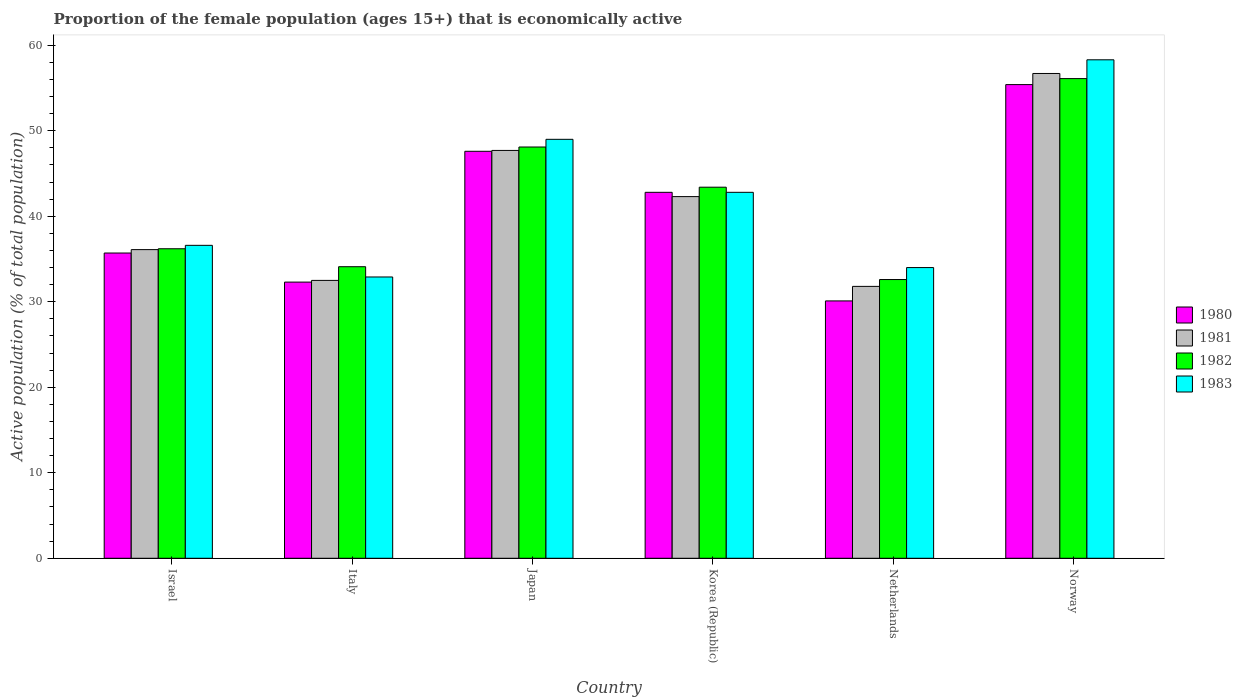How many different coloured bars are there?
Give a very brief answer. 4. How many groups of bars are there?
Make the answer very short. 6. Are the number of bars per tick equal to the number of legend labels?
Offer a very short reply. Yes. Are the number of bars on each tick of the X-axis equal?
Give a very brief answer. Yes. What is the label of the 1st group of bars from the left?
Provide a short and direct response. Israel. In how many cases, is the number of bars for a given country not equal to the number of legend labels?
Give a very brief answer. 0. What is the proportion of the female population that is economically active in 1980 in Norway?
Ensure brevity in your answer.  55.4. Across all countries, what is the maximum proportion of the female population that is economically active in 1982?
Your answer should be compact. 56.1. Across all countries, what is the minimum proportion of the female population that is economically active in 1980?
Give a very brief answer. 30.1. What is the total proportion of the female population that is economically active in 1981 in the graph?
Make the answer very short. 247.1. What is the difference between the proportion of the female population that is economically active in 1982 in Korea (Republic) and the proportion of the female population that is economically active in 1981 in Israel?
Provide a short and direct response. 7.3. What is the average proportion of the female population that is economically active in 1983 per country?
Give a very brief answer. 42.27. What is the difference between the proportion of the female population that is economically active of/in 1982 and proportion of the female population that is economically active of/in 1980 in Italy?
Give a very brief answer. 1.8. What is the ratio of the proportion of the female population that is economically active in 1980 in Korea (Republic) to that in Norway?
Provide a short and direct response. 0.77. Is the proportion of the female population that is economically active in 1981 in Israel less than that in Netherlands?
Your answer should be very brief. No. What is the difference between the highest and the lowest proportion of the female population that is economically active in 1983?
Give a very brief answer. 25.4. In how many countries, is the proportion of the female population that is economically active in 1983 greater than the average proportion of the female population that is economically active in 1983 taken over all countries?
Offer a terse response. 3. What does the 3rd bar from the right in Norway represents?
Provide a succinct answer. 1981. Is it the case that in every country, the sum of the proportion of the female population that is economically active in 1981 and proportion of the female population that is economically active in 1983 is greater than the proportion of the female population that is economically active in 1982?
Provide a short and direct response. Yes. How many countries are there in the graph?
Keep it short and to the point. 6. Does the graph contain any zero values?
Your response must be concise. No. Does the graph contain grids?
Ensure brevity in your answer.  No. Where does the legend appear in the graph?
Provide a short and direct response. Center right. How many legend labels are there?
Give a very brief answer. 4. What is the title of the graph?
Your answer should be very brief. Proportion of the female population (ages 15+) that is economically active. Does "1962" appear as one of the legend labels in the graph?
Offer a terse response. No. What is the label or title of the X-axis?
Your answer should be compact. Country. What is the label or title of the Y-axis?
Your answer should be very brief. Active population (% of total population). What is the Active population (% of total population) in 1980 in Israel?
Provide a short and direct response. 35.7. What is the Active population (% of total population) in 1981 in Israel?
Offer a terse response. 36.1. What is the Active population (% of total population) in 1982 in Israel?
Ensure brevity in your answer.  36.2. What is the Active population (% of total population) in 1983 in Israel?
Ensure brevity in your answer.  36.6. What is the Active population (% of total population) of 1980 in Italy?
Your response must be concise. 32.3. What is the Active population (% of total population) in 1981 in Italy?
Offer a terse response. 32.5. What is the Active population (% of total population) of 1982 in Italy?
Provide a short and direct response. 34.1. What is the Active population (% of total population) of 1983 in Italy?
Make the answer very short. 32.9. What is the Active population (% of total population) of 1980 in Japan?
Provide a succinct answer. 47.6. What is the Active population (% of total population) in 1981 in Japan?
Provide a succinct answer. 47.7. What is the Active population (% of total population) of 1982 in Japan?
Provide a succinct answer. 48.1. What is the Active population (% of total population) of 1980 in Korea (Republic)?
Your response must be concise. 42.8. What is the Active population (% of total population) of 1981 in Korea (Republic)?
Offer a terse response. 42.3. What is the Active population (% of total population) of 1982 in Korea (Republic)?
Keep it short and to the point. 43.4. What is the Active population (% of total population) of 1983 in Korea (Republic)?
Your answer should be compact. 42.8. What is the Active population (% of total population) in 1980 in Netherlands?
Provide a short and direct response. 30.1. What is the Active population (% of total population) in 1981 in Netherlands?
Provide a succinct answer. 31.8. What is the Active population (% of total population) of 1982 in Netherlands?
Make the answer very short. 32.6. What is the Active population (% of total population) of 1983 in Netherlands?
Provide a short and direct response. 34. What is the Active population (% of total population) in 1980 in Norway?
Offer a terse response. 55.4. What is the Active population (% of total population) of 1981 in Norway?
Ensure brevity in your answer.  56.7. What is the Active population (% of total population) of 1982 in Norway?
Provide a succinct answer. 56.1. What is the Active population (% of total population) of 1983 in Norway?
Keep it short and to the point. 58.3. Across all countries, what is the maximum Active population (% of total population) of 1980?
Your response must be concise. 55.4. Across all countries, what is the maximum Active population (% of total population) in 1981?
Provide a succinct answer. 56.7. Across all countries, what is the maximum Active population (% of total population) in 1982?
Offer a terse response. 56.1. Across all countries, what is the maximum Active population (% of total population) of 1983?
Give a very brief answer. 58.3. Across all countries, what is the minimum Active population (% of total population) of 1980?
Keep it short and to the point. 30.1. Across all countries, what is the minimum Active population (% of total population) of 1981?
Provide a succinct answer. 31.8. Across all countries, what is the minimum Active population (% of total population) of 1982?
Offer a terse response. 32.6. Across all countries, what is the minimum Active population (% of total population) in 1983?
Ensure brevity in your answer.  32.9. What is the total Active population (% of total population) in 1980 in the graph?
Offer a very short reply. 243.9. What is the total Active population (% of total population) in 1981 in the graph?
Keep it short and to the point. 247.1. What is the total Active population (% of total population) of 1982 in the graph?
Your answer should be compact. 250.5. What is the total Active population (% of total population) in 1983 in the graph?
Keep it short and to the point. 253.6. What is the difference between the Active population (% of total population) of 1981 in Israel and that in Italy?
Your response must be concise. 3.6. What is the difference between the Active population (% of total population) of 1982 in Israel and that in Italy?
Your answer should be very brief. 2.1. What is the difference between the Active population (% of total population) in 1983 in Israel and that in Italy?
Ensure brevity in your answer.  3.7. What is the difference between the Active population (% of total population) in 1981 in Israel and that in Japan?
Offer a very short reply. -11.6. What is the difference between the Active population (% of total population) in 1983 in Israel and that in Japan?
Offer a terse response. -12.4. What is the difference between the Active population (% of total population) of 1980 in Israel and that in Korea (Republic)?
Offer a terse response. -7.1. What is the difference between the Active population (% of total population) of 1982 in Israel and that in Korea (Republic)?
Ensure brevity in your answer.  -7.2. What is the difference between the Active population (% of total population) in 1981 in Israel and that in Netherlands?
Offer a very short reply. 4.3. What is the difference between the Active population (% of total population) of 1980 in Israel and that in Norway?
Make the answer very short. -19.7. What is the difference between the Active population (% of total population) of 1981 in Israel and that in Norway?
Provide a succinct answer. -20.6. What is the difference between the Active population (% of total population) in 1982 in Israel and that in Norway?
Offer a terse response. -19.9. What is the difference between the Active population (% of total population) of 1983 in Israel and that in Norway?
Make the answer very short. -21.7. What is the difference between the Active population (% of total population) of 1980 in Italy and that in Japan?
Your answer should be compact. -15.3. What is the difference between the Active population (% of total population) of 1981 in Italy and that in Japan?
Provide a succinct answer. -15.2. What is the difference between the Active population (% of total population) of 1983 in Italy and that in Japan?
Make the answer very short. -16.1. What is the difference between the Active population (% of total population) of 1981 in Italy and that in Korea (Republic)?
Provide a succinct answer. -9.8. What is the difference between the Active population (% of total population) of 1982 in Italy and that in Korea (Republic)?
Your response must be concise. -9.3. What is the difference between the Active population (% of total population) in 1983 in Italy and that in Korea (Republic)?
Offer a very short reply. -9.9. What is the difference between the Active population (% of total population) in 1983 in Italy and that in Netherlands?
Your answer should be compact. -1.1. What is the difference between the Active population (% of total population) in 1980 in Italy and that in Norway?
Provide a succinct answer. -23.1. What is the difference between the Active population (% of total population) of 1981 in Italy and that in Norway?
Keep it short and to the point. -24.2. What is the difference between the Active population (% of total population) in 1982 in Italy and that in Norway?
Ensure brevity in your answer.  -22. What is the difference between the Active population (% of total population) in 1983 in Italy and that in Norway?
Your answer should be compact. -25.4. What is the difference between the Active population (% of total population) of 1980 in Japan and that in Korea (Republic)?
Provide a short and direct response. 4.8. What is the difference between the Active population (% of total population) of 1982 in Japan and that in Korea (Republic)?
Keep it short and to the point. 4.7. What is the difference between the Active population (% of total population) of 1980 in Japan and that in Netherlands?
Ensure brevity in your answer.  17.5. What is the difference between the Active population (% of total population) of 1981 in Japan and that in Netherlands?
Provide a short and direct response. 15.9. What is the difference between the Active population (% of total population) in 1982 in Japan and that in Netherlands?
Give a very brief answer. 15.5. What is the difference between the Active population (% of total population) in 1980 in Japan and that in Norway?
Ensure brevity in your answer.  -7.8. What is the difference between the Active population (% of total population) of 1983 in Japan and that in Norway?
Make the answer very short. -9.3. What is the difference between the Active population (% of total population) in 1982 in Korea (Republic) and that in Netherlands?
Provide a succinct answer. 10.8. What is the difference between the Active population (% of total population) of 1983 in Korea (Republic) and that in Netherlands?
Provide a short and direct response. 8.8. What is the difference between the Active population (% of total population) in 1980 in Korea (Republic) and that in Norway?
Your answer should be compact. -12.6. What is the difference between the Active population (% of total population) in 1981 in Korea (Republic) and that in Norway?
Give a very brief answer. -14.4. What is the difference between the Active population (% of total population) in 1982 in Korea (Republic) and that in Norway?
Give a very brief answer. -12.7. What is the difference between the Active population (% of total population) in 1983 in Korea (Republic) and that in Norway?
Make the answer very short. -15.5. What is the difference between the Active population (% of total population) in 1980 in Netherlands and that in Norway?
Offer a very short reply. -25.3. What is the difference between the Active population (% of total population) of 1981 in Netherlands and that in Norway?
Give a very brief answer. -24.9. What is the difference between the Active population (% of total population) of 1982 in Netherlands and that in Norway?
Your answer should be very brief. -23.5. What is the difference between the Active population (% of total population) in 1983 in Netherlands and that in Norway?
Keep it short and to the point. -24.3. What is the difference between the Active population (% of total population) in 1980 in Israel and the Active population (% of total population) in 1981 in Italy?
Your answer should be very brief. 3.2. What is the difference between the Active population (% of total population) in 1980 in Israel and the Active population (% of total population) in 1982 in Italy?
Offer a terse response. 1.6. What is the difference between the Active population (% of total population) in 1980 in Israel and the Active population (% of total population) in 1983 in Italy?
Ensure brevity in your answer.  2.8. What is the difference between the Active population (% of total population) of 1980 in Israel and the Active population (% of total population) of 1981 in Japan?
Your answer should be compact. -12. What is the difference between the Active population (% of total population) of 1980 in Israel and the Active population (% of total population) of 1982 in Japan?
Ensure brevity in your answer.  -12.4. What is the difference between the Active population (% of total population) of 1981 in Israel and the Active population (% of total population) of 1983 in Japan?
Offer a very short reply. -12.9. What is the difference between the Active population (% of total population) of 1981 in Israel and the Active population (% of total population) of 1982 in Korea (Republic)?
Your answer should be compact. -7.3. What is the difference between the Active population (% of total population) of 1981 in Israel and the Active population (% of total population) of 1983 in Korea (Republic)?
Offer a terse response. -6.7. What is the difference between the Active population (% of total population) in 1980 in Israel and the Active population (% of total population) in 1981 in Netherlands?
Provide a short and direct response. 3.9. What is the difference between the Active population (% of total population) in 1980 in Israel and the Active population (% of total population) in 1982 in Netherlands?
Your response must be concise. 3.1. What is the difference between the Active population (% of total population) of 1981 in Israel and the Active population (% of total population) of 1983 in Netherlands?
Ensure brevity in your answer.  2.1. What is the difference between the Active population (% of total population) of 1982 in Israel and the Active population (% of total population) of 1983 in Netherlands?
Your answer should be compact. 2.2. What is the difference between the Active population (% of total population) in 1980 in Israel and the Active population (% of total population) in 1981 in Norway?
Make the answer very short. -21. What is the difference between the Active population (% of total population) in 1980 in Israel and the Active population (% of total population) in 1982 in Norway?
Your answer should be very brief. -20.4. What is the difference between the Active population (% of total population) of 1980 in Israel and the Active population (% of total population) of 1983 in Norway?
Provide a succinct answer. -22.6. What is the difference between the Active population (% of total population) in 1981 in Israel and the Active population (% of total population) in 1982 in Norway?
Provide a short and direct response. -20. What is the difference between the Active population (% of total population) in 1981 in Israel and the Active population (% of total population) in 1983 in Norway?
Make the answer very short. -22.2. What is the difference between the Active population (% of total population) in 1982 in Israel and the Active population (% of total population) in 1983 in Norway?
Keep it short and to the point. -22.1. What is the difference between the Active population (% of total population) in 1980 in Italy and the Active population (% of total population) in 1981 in Japan?
Your answer should be very brief. -15.4. What is the difference between the Active population (% of total population) in 1980 in Italy and the Active population (% of total population) in 1982 in Japan?
Ensure brevity in your answer.  -15.8. What is the difference between the Active population (% of total population) of 1980 in Italy and the Active population (% of total population) of 1983 in Japan?
Offer a very short reply. -16.7. What is the difference between the Active population (% of total population) of 1981 in Italy and the Active population (% of total population) of 1982 in Japan?
Ensure brevity in your answer.  -15.6. What is the difference between the Active population (% of total population) of 1981 in Italy and the Active population (% of total population) of 1983 in Japan?
Your response must be concise. -16.5. What is the difference between the Active population (% of total population) in 1982 in Italy and the Active population (% of total population) in 1983 in Japan?
Offer a very short reply. -14.9. What is the difference between the Active population (% of total population) of 1980 in Italy and the Active population (% of total population) of 1983 in Korea (Republic)?
Your answer should be very brief. -10.5. What is the difference between the Active population (% of total population) of 1981 in Italy and the Active population (% of total population) of 1982 in Korea (Republic)?
Offer a very short reply. -10.9. What is the difference between the Active population (% of total population) of 1980 in Italy and the Active population (% of total population) of 1981 in Netherlands?
Give a very brief answer. 0.5. What is the difference between the Active population (% of total population) in 1980 in Italy and the Active population (% of total population) in 1982 in Netherlands?
Your answer should be compact. -0.3. What is the difference between the Active population (% of total population) in 1981 in Italy and the Active population (% of total population) in 1982 in Netherlands?
Provide a succinct answer. -0.1. What is the difference between the Active population (% of total population) in 1981 in Italy and the Active population (% of total population) in 1983 in Netherlands?
Offer a very short reply. -1.5. What is the difference between the Active population (% of total population) in 1982 in Italy and the Active population (% of total population) in 1983 in Netherlands?
Your response must be concise. 0.1. What is the difference between the Active population (% of total population) of 1980 in Italy and the Active population (% of total population) of 1981 in Norway?
Your answer should be very brief. -24.4. What is the difference between the Active population (% of total population) of 1980 in Italy and the Active population (% of total population) of 1982 in Norway?
Offer a terse response. -23.8. What is the difference between the Active population (% of total population) of 1981 in Italy and the Active population (% of total population) of 1982 in Norway?
Keep it short and to the point. -23.6. What is the difference between the Active population (% of total population) of 1981 in Italy and the Active population (% of total population) of 1983 in Norway?
Keep it short and to the point. -25.8. What is the difference between the Active population (% of total population) of 1982 in Italy and the Active population (% of total population) of 1983 in Norway?
Your answer should be compact. -24.2. What is the difference between the Active population (% of total population) in 1980 in Japan and the Active population (% of total population) in 1983 in Korea (Republic)?
Provide a succinct answer. 4.8. What is the difference between the Active population (% of total population) of 1981 in Japan and the Active population (% of total population) of 1982 in Korea (Republic)?
Your answer should be very brief. 4.3. What is the difference between the Active population (% of total population) of 1981 in Japan and the Active population (% of total population) of 1983 in Korea (Republic)?
Keep it short and to the point. 4.9. What is the difference between the Active population (% of total population) of 1982 in Japan and the Active population (% of total population) of 1983 in Korea (Republic)?
Keep it short and to the point. 5.3. What is the difference between the Active population (% of total population) of 1980 in Japan and the Active population (% of total population) of 1981 in Netherlands?
Your answer should be compact. 15.8. What is the difference between the Active population (% of total population) of 1980 in Japan and the Active population (% of total population) of 1982 in Netherlands?
Keep it short and to the point. 15. What is the difference between the Active population (% of total population) in 1981 in Japan and the Active population (% of total population) in 1982 in Netherlands?
Make the answer very short. 15.1. What is the difference between the Active population (% of total population) in 1981 in Japan and the Active population (% of total population) in 1983 in Netherlands?
Your answer should be very brief. 13.7. What is the difference between the Active population (% of total population) in 1982 in Japan and the Active population (% of total population) in 1983 in Netherlands?
Your answer should be very brief. 14.1. What is the difference between the Active population (% of total population) of 1980 in Japan and the Active population (% of total population) of 1982 in Norway?
Your answer should be compact. -8.5. What is the difference between the Active population (% of total population) in 1981 in Japan and the Active population (% of total population) in 1983 in Norway?
Give a very brief answer. -10.6. What is the difference between the Active population (% of total population) of 1982 in Korea (Republic) and the Active population (% of total population) of 1983 in Netherlands?
Your answer should be compact. 9.4. What is the difference between the Active population (% of total population) of 1980 in Korea (Republic) and the Active population (% of total population) of 1981 in Norway?
Keep it short and to the point. -13.9. What is the difference between the Active population (% of total population) in 1980 in Korea (Republic) and the Active population (% of total population) in 1982 in Norway?
Provide a succinct answer. -13.3. What is the difference between the Active population (% of total population) in 1980 in Korea (Republic) and the Active population (% of total population) in 1983 in Norway?
Provide a short and direct response. -15.5. What is the difference between the Active population (% of total population) in 1982 in Korea (Republic) and the Active population (% of total population) in 1983 in Norway?
Offer a terse response. -14.9. What is the difference between the Active population (% of total population) of 1980 in Netherlands and the Active population (% of total population) of 1981 in Norway?
Make the answer very short. -26.6. What is the difference between the Active population (% of total population) of 1980 in Netherlands and the Active population (% of total population) of 1982 in Norway?
Offer a very short reply. -26. What is the difference between the Active population (% of total population) in 1980 in Netherlands and the Active population (% of total population) in 1983 in Norway?
Your answer should be compact. -28.2. What is the difference between the Active population (% of total population) in 1981 in Netherlands and the Active population (% of total population) in 1982 in Norway?
Provide a short and direct response. -24.3. What is the difference between the Active population (% of total population) in 1981 in Netherlands and the Active population (% of total population) in 1983 in Norway?
Make the answer very short. -26.5. What is the difference between the Active population (% of total population) of 1982 in Netherlands and the Active population (% of total population) of 1983 in Norway?
Provide a short and direct response. -25.7. What is the average Active population (% of total population) in 1980 per country?
Provide a short and direct response. 40.65. What is the average Active population (% of total population) of 1981 per country?
Provide a short and direct response. 41.18. What is the average Active population (% of total population) in 1982 per country?
Your answer should be compact. 41.75. What is the average Active population (% of total population) of 1983 per country?
Offer a very short reply. 42.27. What is the difference between the Active population (% of total population) of 1980 and Active population (% of total population) of 1982 in Israel?
Your answer should be compact. -0.5. What is the difference between the Active population (% of total population) in 1981 and Active population (% of total population) in 1982 in Israel?
Offer a terse response. -0.1. What is the difference between the Active population (% of total population) in 1982 and Active population (% of total population) in 1983 in Israel?
Make the answer very short. -0.4. What is the difference between the Active population (% of total population) of 1980 and Active population (% of total population) of 1982 in Italy?
Ensure brevity in your answer.  -1.8. What is the difference between the Active population (% of total population) of 1980 and Active population (% of total population) of 1983 in Italy?
Your answer should be compact. -0.6. What is the difference between the Active population (% of total population) in 1981 and Active population (% of total population) in 1983 in Italy?
Provide a succinct answer. -0.4. What is the difference between the Active population (% of total population) of 1982 and Active population (% of total population) of 1983 in Italy?
Your answer should be compact. 1.2. What is the difference between the Active population (% of total population) in 1981 and Active population (% of total population) in 1982 in Japan?
Your answer should be very brief. -0.4. What is the difference between the Active population (% of total population) in 1980 and Active population (% of total population) in 1981 in Korea (Republic)?
Provide a short and direct response. 0.5. What is the difference between the Active population (% of total population) in 1980 and Active population (% of total population) in 1982 in Korea (Republic)?
Your answer should be compact. -0.6. What is the difference between the Active population (% of total population) of 1980 and Active population (% of total population) of 1983 in Netherlands?
Ensure brevity in your answer.  -3.9. What is the difference between the Active population (% of total population) in 1980 and Active population (% of total population) in 1981 in Norway?
Keep it short and to the point. -1.3. What is the difference between the Active population (% of total population) in 1980 and Active population (% of total population) in 1982 in Norway?
Your answer should be very brief. -0.7. What is the difference between the Active population (% of total population) in 1981 and Active population (% of total population) in 1983 in Norway?
Give a very brief answer. -1.6. What is the ratio of the Active population (% of total population) in 1980 in Israel to that in Italy?
Offer a terse response. 1.11. What is the ratio of the Active population (% of total population) of 1981 in Israel to that in Italy?
Provide a short and direct response. 1.11. What is the ratio of the Active population (% of total population) of 1982 in Israel to that in Italy?
Your response must be concise. 1.06. What is the ratio of the Active population (% of total population) in 1983 in Israel to that in Italy?
Give a very brief answer. 1.11. What is the ratio of the Active population (% of total population) in 1980 in Israel to that in Japan?
Give a very brief answer. 0.75. What is the ratio of the Active population (% of total population) of 1981 in Israel to that in Japan?
Provide a succinct answer. 0.76. What is the ratio of the Active population (% of total population) in 1982 in Israel to that in Japan?
Your answer should be compact. 0.75. What is the ratio of the Active population (% of total population) of 1983 in Israel to that in Japan?
Give a very brief answer. 0.75. What is the ratio of the Active population (% of total population) in 1980 in Israel to that in Korea (Republic)?
Offer a very short reply. 0.83. What is the ratio of the Active population (% of total population) in 1981 in Israel to that in Korea (Republic)?
Offer a terse response. 0.85. What is the ratio of the Active population (% of total population) of 1982 in Israel to that in Korea (Republic)?
Your answer should be very brief. 0.83. What is the ratio of the Active population (% of total population) of 1983 in Israel to that in Korea (Republic)?
Keep it short and to the point. 0.86. What is the ratio of the Active population (% of total population) in 1980 in Israel to that in Netherlands?
Your answer should be very brief. 1.19. What is the ratio of the Active population (% of total population) in 1981 in Israel to that in Netherlands?
Provide a short and direct response. 1.14. What is the ratio of the Active population (% of total population) of 1982 in Israel to that in Netherlands?
Provide a succinct answer. 1.11. What is the ratio of the Active population (% of total population) in 1983 in Israel to that in Netherlands?
Offer a terse response. 1.08. What is the ratio of the Active population (% of total population) of 1980 in Israel to that in Norway?
Provide a succinct answer. 0.64. What is the ratio of the Active population (% of total population) of 1981 in Israel to that in Norway?
Provide a short and direct response. 0.64. What is the ratio of the Active population (% of total population) in 1982 in Israel to that in Norway?
Provide a succinct answer. 0.65. What is the ratio of the Active population (% of total population) in 1983 in Israel to that in Norway?
Keep it short and to the point. 0.63. What is the ratio of the Active population (% of total population) in 1980 in Italy to that in Japan?
Offer a terse response. 0.68. What is the ratio of the Active population (% of total population) of 1981 in Italy to that in Japan?
Keep it short and to the point. 0.68. What is the ratio of the Active population (% of total population) of 1982 in Italy to that in Japan?
Ensure brevity in your answer.  0.71. What is the ratio of the Active population (% of total population) of 1983 in Italy to that in Japan?
Make the answer very short. 0.67. What is the ratio of the Active population (% of total population) in 1980 in Italy to that in Korea (Republic)?
Offer a very short reply. 0.75. What is the ratio of the Active population (% of total population) in 1981 in Italy to that in Korea (Republic)?
Provide a succinct answer. 0.77. What is the ratio of the Active population (% of total population) of 1982 in Italy to that in Korea (Republic)?
Your answer should be compact. 0.79. What is the ratio of the Active population (% of total population) in 1983 in Italy to that in Korea (Republic)?
Provide a succinct answer. 0.77. What is the ratio of the Active population (% of total population) of 1980 in Italy to that in Netherlands?
Make the answer very short. 1.07. What is the ratio of the Active population (% of total population) of 1981 in Italy to that in Netherlands?
Ensure brevity in your answer.  1.02. What is the ratio of the Active population (% of total population) in 1982 in Italy to that in Netherlands?
Your response must be concise. 1.05. What is the ratio of the Active population (% of total population) in 1983 in Italy to that in Netherlands?
Offer a very short reply. 0.97. What is the ratio of the Active population (% of total population) in 1980 in Italy to that in Norway?
Provide a short and direct response. 0.58. What is the ratio of the Active population (% of total population) of 1981 in Italy to that in Norway?
Make the answer very short. 0.57. What is the ratio of the Active population (% of total population) of 1982 in Italy to that in Norway?
Provide a short and direct response. 0.61. What is the ratio of the Active population (% of total population) in 1983 in Italy to that in Norway?
Provide a short and direct response. 0.56. What is the ratio of the Active population (% of total population) of 1980 in Japan to that in Korea (Republic)?
Your answer should be very brief. 1.11. What is the ratio of the Active population (% of total population) in 1981 in Japan to that in Korea (Republic)?
Your answer should be very brief. 1.13. What is the ratio of the Active population (% of total population) in 1982 in Japan to that in Korea (Republic)?
Keep it short and to the point. 1.11. What is the ratio of the Active population (% of total population) of 1983 in Japan to that in Korea (Republic)?
Offer a very short reply. 1.14. What is the ratio of the Active population (% of total population) of 1980 in Japan to that in Netherlands?
Offer a terse response. 1.58. What is the ratio of the Active population (% of total population) in 1982 in Japan to that in Netherlands?
Offer a terse response. 1.48. What is the ratio of the Active population (% of total population) of 1983 in Japan to that in Netherlands?
Offer a very short reply. 1.44. What is the ratio of the Active population (% of total population) of 1980 in Japan to that in Norway?
Ensure brevity in your answer.  0.86. What is the ratio of the Active population (% of total population) in 1981 in Japan to that in Norway?
Give a very brief answer. 0.84. What is the ratio of the Active population (% of total population) of 1982 in Japan to that in Norway?
Offer a very short reply. 0.86. What is the ratio of the Active population (% of total population) of 1983 in Japan to that in Norway?
Give a very brief answer. 0.84. What is the ratio of the Active population (% of total population) of 1980 in Korea (Republic) to that in Netherlands?
Your response must be concise. 1.42. What is the ratio of the Active population (% of total population) in 1981 in Korea (Republic) to that in Netherlands?
Give a very brief answer. 1.33. What is the ratio of the Active population (% of total population) in 1982 in Korea (Republic) to that in Netherlands?
Provide a short and direct response. 1.33. What is the ratio of the Active population (% of total population) in 1983 in Korea (Republic) to that in Netherlands?
Give a very brief answer. 1.26. What is the ratio of the Active population (% of total population) in 1980 in Korea (Republic) to that in Norway?
Make the answer very short. 0.77. What is the ratio of the Active population (% of total population) in 1981 in Korea (Republic) to that in Norway?
Your answer should be compact. 0.75. What is the ratio of the Active population (% of total population) in 1982 in Korea (Republic) to that in Norway?
Give a very brief answer. 0.77. What is the ratio of the Active population (% of total population) of 1983 in Korea (Republic) to that in Norway?
Your answer should be very brief. 0.73. What is the ratio of the Active population (% of total population) in 1980 in Netherlands to that in Norway?
Provide a short and direct response. 0.54. What is the ratio of the Active population (% of total population) of 1981 in Netherlands to that in Norway?
Your answer should be very brief. 0.56. What is the ratio of the Active population (% of total population) of 1982 in Netherlands to that in Norway?
Your answer should be compact. 0.58. What is the ratio of the Active population (% of total population) of 1983 in Netherlands to that in Norway?
Provide a succinct answer. 0.58. What is the difference between the highest and the second highest Active population (% of total population) of 1982?
Your answer should be compact. 8. What is the difference between the highest and the second highest Active population (% of total population) of 1983?
Offer a very short reply. 9.3. What is the difference between the highest and the lowest Active population (% of total population) of 1980?
Provide a short and direct response. 25.3. What is the difference between the highest and the lowest Active population (% of total population) in 1981?
Keep it short and to the point. 24.9. What is the difference between the highest and the lowest Active population (% of total population) in 1982?
Your answer should be compact. 23.5. What is the difference between the highest and the lowest Active population (% of total population) in 1983?
Your response must be concise. 25.4. 